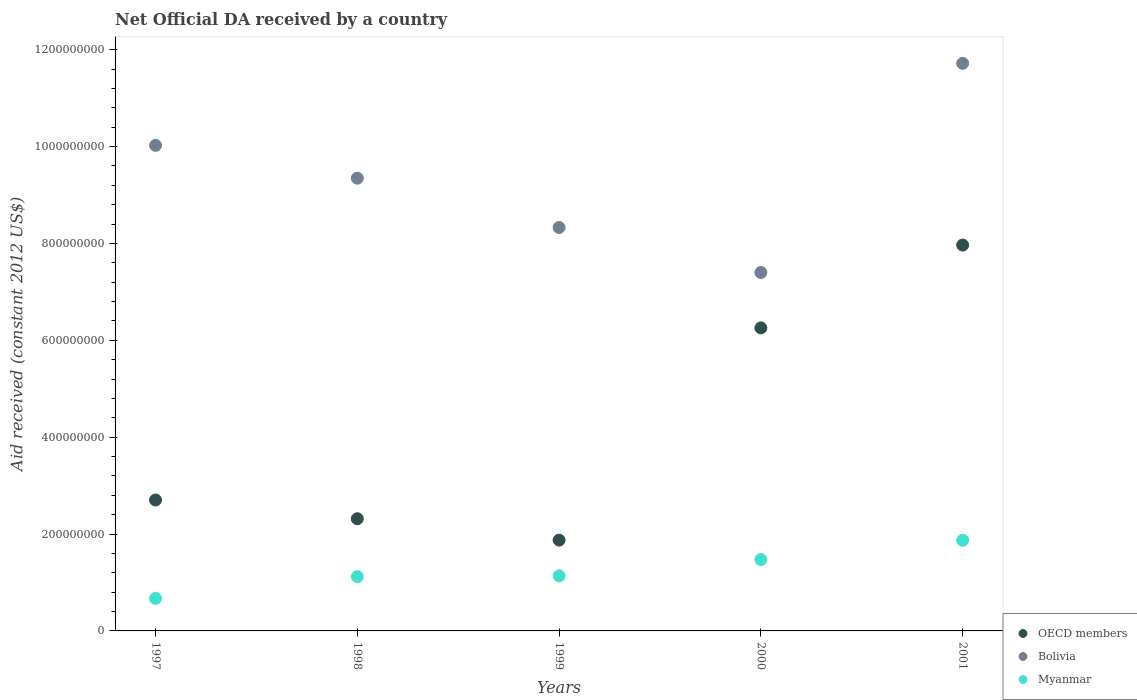How many different coloured dotlines are there?
Provide a succinct answer. 3. Is the number of dotlines equal to the number of legend labels?
Provide a short and direct response. Yes. What is the net official development assistance aid received in Bolivia in 2001?
Provide a short and direct response. 1.17e+09. Across all years, what is the maximum net official development assistance aid received in OECD members?
Provide a succinct answer. 7.97e+08. Across all years, what is the minimum net official development assistance aid received in OECD members?
Keep it short and to the point. 1.88e+08. In which year was the net official development assistance aid received in Bolivia maximum?
Offer a very short reply. 2001. What is the total net official development assistance aid received in OECD members in the graph?
Offer a terse response. 2.11e+09. What is the difference between the net official development assistance aid received in Bolivia in 2000 and that in 2001?
Ensure brevity in your answer.  -4.32e+08. What is the difference between the net official development assistance aid received in OECD members in 1997 and the net official development assistance aid received in Myanmar in 1999?
Offer a very short reply. 1.57e+08. What is the average net official development assistance aid received in OECD members per year?
Provide a succinct answer. 4.22e+08. In the year 2000, what is the difference between the net official development assistance aid received in Bolivia and net official development assistance aid received in Myanmar?
Provide a short and direct response. 5.93e+08. In how many years, is the net official development assistance aid received in Bolivia greater than 760000000 US$?
Provide a short and direct response. 4. What is the ratio of the net official development assistance aid received in Myanmar in 1998 to that in 2001?
Provide a succinct answer. 0.6. Is the net official development assistance aid received in OECD members in 1997 less than that in 2001?
Give a very brief answer. Yes. What is the difference between the highest and the second highest net official development assistance aid received in Myanmar?
Make the answer very short. 3.98e+07. What is the difference between the highest and the lowest net official development assistance aid received in OECD members?
Provide a succinct answer. 6.09e+08. In how many years, is the net official development assistance aid received in OECD members greater than the average net official development assistance aid received in OECD members taken over all years?
Offer a very short reply. 2. Does the net official development assistance aid received in Bolivia monotonically increase over the years?
Your answer should be very brief. No. Is the net official development assistance aid received in OECD members strictly greater than the net official development assistance aid received in Bolivia over the years?
Ensure brevity in your answer.  No. Is the net official development assistance aid received in Bolivia strictly less than the net official development assistance aid received in Myanmar over the years?
Your answer should be compact. No. How many years are there in the graph?
Provide a short and direct response. 5. Are the values on the major ticks of Y-axis written in scientific E-notation?
Your response must be concise. No. Where does the legend appear in the graph?
Offer a very short reply. Bottom right. How many legend labels are there?
Make the answer very short. 3. How are the legend labels stacked?
Your answer should be very brief. Vertical. What is the title of the graph?
Give a very brief answer. Net Official DA received by a country. What is the label or title of the X-axis?
Offer a very short reply. Years. What is the label or title of the Y-axis?
Make the answer very short. Aid received (constant 2012 US$). What is the Aid received (constant 2012 US$) of OECD members in 1997?
Offer a terse response. 2.70e+08. What is the Aid received (constant 2012 US$) of Bolivia in 1997?
Offer a terse response. 1.00e+09. What is the Aid received (constant 2012 US$) of Myanmar in 1997?
Provide a succinct answer. 6.71e+07. What is the Aid received (constant 2012 US$) of OECD members in 1998?
Give a very brief answer. 2.32e+08. What is the Aid received (constant 2012 US$) in Bolivia in 1998?
Offer a very short reply. 9.35e+08. What is the Aid received (constant 2012 US$) of Myanmar in 1998?
Offer a terse response. 1.12e+08. What is the Aid received (constant 2012 US$) in OECD members in 1999?
Offer a terse response. 1.88e+08. What is the Aid received (constant 2012 US$) of Bolivia in 1999?
Offer a terse response. 8.33e+08. What is the Aid received (constant 2012 US$) of Myanmar in 1999?
Provide a succinct answer. 1.14e+08. What is the Aid received (constant 2012 US$) of OECD members in 2000?
Provide a succinct answer. 6.26e+08. What is the Aid received (constant 2012 US$) in Bolivia in 2000?
Offer a terse response. 7.40e+08. What is the Aid received (constant 2012 US$) of Myanmar in 2000?
Offer a very short reply. 1.47e+08. What is the Aid received (constant 2012 US$) in OECD members in 2001?
Ensure brevity in your answer.  7.97e+08. What is the Aid received (constant 2012 US$) of Bolivia in 2001?
Provide a short and direct response. 1.17e+09. What is the Aid received (constant 2012 US$) in Myanmar in 2001?
Give a very brief answer. 1.87e+08. Across all years, what is the maximum Aid received (constant 2012 US$) of OECD members?
Your answer should be very brief. 7.97e+08. Across all years, what is the maximum Aid received (constant 2012 US$) of Bolivia?
Offer a very short reply. 1.17e+09. Across all years, what is the maximum Aid received (constant 2012 US$) of Myanmar?
Make the answer very short. 1.87e+08. Across all years, what is the minimum Aid received (constant 2012 US$) in OECD members?
Give a very brief answer. 1.88e+08. Across all years, what is the minimum Aid received (constant 2012 US$) of Bolivia?
Provide a succinct answer. 7.40e+08. Across all years, what is the minimum Aid received (constant 2012 US$) of Myanmar?
Give a very brief answer. 6.71e+07. What is the total Aid received (constant 2012 US$) in OECD members in the graph?
Keep it short and to the point. 2.11e+09. What is the total Aid received (constant 2012 US$) in Bolivia in the graph?
Provide a short and direct response. 4.68e+09. What is the total Aid received (constant 2012 US$) in Myanmar in the graph?
Provide a short and direct response. 6.28e+08. What is the difference between the Aid received (constant 2012 US$) of OECD members in 1997 and that in 1998?
Offer a very short reply. 3.87e+07. What is the difference between the Aid received (constant 2012 US$) in Bolivia in 1997 and that in 1998?
Provide a succinct answer. 6.77e+07. What is the difference between the Aid received (constant 2012 US$) in Myanmar in 1997 and that in 1998?
Your answer should be very brief. -4.50e+07. What is the difference between the Aid received (constant 2012 US$) in OECD members in 1997 and that in 1999?
Keep it short and to the point. 8.28e+07. What is the difference between the Aid received (constant 2012 US$) of Bolivia in 1997 and that in 1999?
Your answer should be very brief. 1.70e+08. What is the difference between the Aid received (constant 2012 US$) in Myanmar in 1997 and that in 1999?
Your answer should be compact. -4.66e+07. What is the difference between the Aid received (constant 2012 US$) of OECD members in 1997 and that in 2000?
Give a very brief answer. -3.55e+08. What is the difference between the Aid received (constant 2012 US$) in Bolivia in 1997 and that in 2000?
Provide a short and direct response. 2.62e+08. What is the difference between the Aid received (constant 2012 US$) of Myanmar in 1997 and that in 2000?
Your response must be concise. -8.03e+07. What is the difference between the Aid received (constant 2012 US$) of OECD members in 1997 and that in 2001?
Provide a short and direct response. -5.26e+08. What is the difference between the Aid received (constant 2012 US$) in Bolivia in 1997 and that in 2001?
Ensure brevity in your answer.  -1.69e+08. What is the difference between the Aid received (constant 2012 US$) in Myanmar in 1997 and that in 2001?
Provide a short and direct response. -1.20e+08. What is the difference between the Aid received (constant 2012 US$) in OECD members in 1998 and that in 1999?
Your answer should be very brief. 4.41e+07. What is the difference between the Aid received (constant 2012 US$) in Bolivia in 1998 and that in 1999?
Keep it short and to the point. 1.02e+08. What is the difference between the Aid received (constant 2012 US$) in Myanmar in 1998 and that in 1999?
Provide a succinct answer. -1.68e+06. What is the difference between the Aid received (constant 2012 US$) of OECD members in 1998 and that in 2000?
Make the answer very short. -3.94e+08. What is the difference between the Aid received (constant 2012 US$) of Bolivia in 1998 and that in 2000?
Make the answer very short. 1.95e+08. What is the difference between the Aid received (constant 2012 US$) in Myanmar in 1998 and that in 2000?
Ensure brevity in your answer.  -3.53e+07. What is the difference between the Aid received (constant 2012 US$) in OECD members in 1998 and that in 2001?
Your answer should be compact. -5.65e+08. What is the difference between the Aid received (constant 2012 US$) of Bolivia in 1998 and that in 2001?
Give a very brief answer. -2.37e+08. What is the difference between the Aid received (constant 2012 US$) of Myanmar in 1998 and that in 2001?
Ensure brevity in your answer.  -7.51e+07. What is the difference between the Aid received (constant 2012 US$) in OECD members in 1999 and that in 2000?
Keep it short and to the point. -4.38e+08. What is the difference between the Aid received (constant 2012 US$) in Bolivia in 1999 and that in 2000?
Provide a succinct answer. 9.29e+07. What is the difference between the Aid received (constant 2012 US$) of Myanmar in 1999 and that in 2000?
Offer a very short reply. -3.37e+07. What is the difference between the Aid received (constant 2012 US$) in OECD members in 1999 and that in 2001?
Keep it short and to the point. -6.09e+08. What is the difference between the Aid received (constant 2012 US$) of Bolivia in 1999 and that in 2001?
Your response must be concise. -3.39e+08. What is the difference between the Aid received (constant 2012 US$) in Myanmar in 1999 and that in 2001?
Offer a terse response. -7.34e+07. What is the difference between the Aid received (constant 2012 US$) of OECD members in 2000 and that in 2001?
Ensure brevity in your answer.  -1.71e+08. What is the difference between the Aid received (constant 2012 US$) in Bolivia in 2000 and that in 2001?
Make the answer very short. -4.32e+08. What is the difference between the Aid received (constant 2012 US$) of Myanmar in 2000 and that in 2001?
Offer a terse response. -3.98e+07. What is the difference between the Aid received (constant 2012 US$) in OECD members in 1997 and the Aid received (constant 2012 US$) in Bolivia in 1998?
Ensure brevity in your answer.  -6.64e+08. What is the difference between the Aid received (constant 2012 US$) in OECD members in 1997 and the Aid received (constant 2012 US$) in Myanmar in 1998?
Your answer should be very brief. 1.58e+08. What is the difference between the Aid received (constant 2012 US$) of Bolivia in 1997 and the Aid received (constant 2012 US$) of Myanmar in 1998?
Make the answer very short. 8.90e+08. What is the difference between the Aid received (constant 2012 US$) of OECD members in 1997 and the Aid received (constant 2012 US$) of Bolivia in 1999?
Provide a short and direct response. -5.63e+08. What is the difference between the Aid received (constant 2012 US$) in OECD members in 1997 and the Aid received (constant 2012 US$) in Myanmar in 1999?
Give a very brief answer. 1.57e+08. What is the difference between the Aid received (constant 2012 US$) in Bolivia in 1997 and the Aid received (constant 2012 US$) in Myanmar in 1999?
Your answer should be very brief. 8.89e+08. What is the difference between the Aid received (constant 2012 US$) in OECD members in 1997 and the Aid received (constant 2012 US$) in Bolivia in 2000?
Give a very brief answer. -4.70e+08. What is the difference between the Aid received (constant 2012 US$) in OECD members in 1997 and the Aid received (constant 2012 US$) in Myanmar in 2000?
Your response must be concise. 1.23e+08. What is the difference between the Aid received (constant 2012 US$) of Bolivia in 1997 and the Aid received (constant 2012 US$) of Myanmar in 2000?
Offer a terse response. 8.55e+08. What is the difference between the Aid received (constant 2012 US$) of OECD members in 1997 and the Aid received (constant 2012 US$) of Bolivia in 2001?
Offer a very short reply. -9.02e+08. What is the difference between the Aid received (constant 2012 US$) of OECD members in 1997 and the Aid received (constant 2012 US$) of Myanmar in 2001?
Your response must be concise. 8.32e+07. What is the difference between the Aid received (constant 2012 US$) of Bolivia in 1997 and the Aid received (constant 2012 US$) of Myanmar in 2001?
Provide a short and direct response. 8.15e+08. What is the difference between the Aid received (constant 2012 US$) of OECD members in 1998 and the Aid received (constant 2012 US$) of Bolivia in 1999?
Provide a short and direct response. -6.01e+08. What is the difference between the Aid received (constant 2012 US$) of OECD members in 1998 and the Aid received (constant 2012 US$) of Myanmar in 1999?
Keep it short and to the point. 1.18e+08. What is the difference between the Aid received (constant 2012 US$) of Bolivia in 1998 and the Aid received (constant 2012 US$) of Myanmar in 1999?
Your answer should be compact. 8.21e+08. What is the difference between the Aid received (constant 2012 US$) of OECD members in 1998 and the Aid received (constant 2012 US$) of Bolivia in 2000?
Your response must be concise. -5.08e+08. What is the difference between the Aid received (constant 2012 US$) in OECD members in 1998 and the Aid received (constant 2012 US$) in Myanmar in 2000?
Ensure brevity in your answer.  8.42e+07. What is the difference between the Aid received (constant 2012 US$) in Bolivia in 1998 and the Aid received (constant 2012 US$) in Myanmar in 2000?
Ensure brevity in your answer.  7.87e+08. What is the difference between the Aid received (constant 2012 US$) of OECD members in 1998 and the Aid received (constant 2012 US$) of Bolivia in 2001?
Offer a terse response. -9.40e+08. What is the difference between the Aid received (constant 2012 US$) in OECD members in 1998 and the Aid received (constant 2012 US$) in Myanmar in 2001?
Offer a very short reply. 4.44e+07. What is the difference between the Aid received (constant 2012 US$) in Bolivia in 1998 and the Aid received (constant 2012 US$) in Myanmar in 2001?
Your answer should be very brief. 7.48e+08. What is the difference between the Aid received (constant 2012 US$) in OECD members in 1999 and the Aid received (constant 2012 US$) in Bolivia in 2000?
Keep it short and to the point. -5.53e+08. What is the difference between the Aid received (constant 2012 US$) in OECD members in 1999 and the Aid received (constant 2012 US$) in Myanmar in 2000?
Provide a succinct answer. 4.01e+07. What is the difference between the Aid received (constant 2012 US$) of Bolivia in 1999 and the Aid received (constant 2012 US$) of Myanmar in 2000?
Ensure brevity in your answer.  6.86e+08. What is the difference between the Aid received (constant 2012 US$) in OECD members in 1999 and the Aid received (constant 2012 US$) in Bolivia in 2001?
Your answer should be compact. -9.84e+08. What is the difference between the Aid received (constant 2012 US$) of Bolivia in 1999 and the Aid received (constant 2012 US$) of Myanmar in 2001?
Provide a succinct answer. 6.46e+08. What is the difference between the Aid received (constant 2012 US$) of OECD members in 2000 and the Aid received (constant 2012 US$) of Bolivia in 2001?
Your answer should be compact. -5.46e+08. What is the difference between the Aid received (constant 2012 US$) in OECD members in 2000 and the Aid received (constant 2012 US$) in Myanmar in 2001?
Make the answer very short. 4.38e+08. What is the difference between the Aid received (constant 2012 US$) of Bolivia in 2000 and the Aid received (constant 2012 US$) of Myanmar in 2001?
Your response must be concise. 5.53e+08. What is the average Aid received (constant 2012 US$) of OECD members per year?
Give a very brief answer. 4.22e+08. What is the average Aid received (constant 2012 US$) of Bolivia per year?
Give a very brief answer. 9.36e+08. What is the average Aid received (constant 2012 US$) of Myanmar per year?
Your response must be concise. 1.26e+08. In the year 1997, what is the difference between the Aid received (constant 2012 US$) in OECD members and Aid received (constant 2012 US$) in Bolivia?
Keep it short and to the point. -7.32e+08. In the year 1997, what is the difference between the Aid received (constant 2012 US$) in OECD members and Aid received (constant 2012 US$) in Myanmar?
Your response must be concise. 2.03e+08. In the year 1997, what is the difference between the Aid received (constant 2012 US$) in Bolivia and Aid received (constant 2012 US$) in Myanmar?
Your answer should be very brief. 9.35e+08. In the year 1998, what is the difference between the Aid received (constant 2012 US$) in OECD members and Aid received (constant 2012 US$) in Bolivia?
Provide a succinct answer. -7.03e+08. In the year 1998, what is the difference between the Aid received (constant 2012 US$) of OECD members and Aid received (constant 2012 US$) of Myanmar?
Ensure brevity in your answer.  1.20e+08. In the year 1998, what is the difference between the Aid received (constant 2012 US$) of Bolivia and Aid received (constant 2012 US$) of Myanmar?
Provide a short and direct response. 8.23e+08. In the year 1999, what is the difference between the Aid received (constant 2012 US$) of OECD members and Aid received (constant 2012 US$) of Bolivia?
Offer a terse response. -6.45e+08. In the year 1999, what is the difference between the Aid received (constant 2012 US$) in OECD members and Aid received (constant 2012 US$) in Myanmar?
Offer a terse response. 7.38e+07. In the year 1999, what is the difference between the Aid received (constant 2012 US$) in Bolivia and Aid received (constant 2012 US$) in Myanmar?
Offer a terse response. 7.19e+08. In the year 2000, what is the difference between the Aid received (constant 2012 US$) in OECD members and Aid received (constant 2012 US$) in Bolivia?
Keep it short and to the point. -1.14e+08. In the year 2000, what is the difference between the Aid received (constant 2012 US$) in OECD members and Aid received (constant 2012 US$) in Myanmar?
Your response must be concise. 4.78e+08. In the year 2000, what is the difference between the Aid received (constant 2012 US$) in Bolivia and Aid received (constant 2012 US$) in Myanmar?
Give a very brief answer. 5.93e+08. In the year 2001, what is the difference between the Aid received (constant 2012 US$) in OECD members and Aid received (constant 2012 US$) in Bolivia?
Offer a very short reply. -3.75e+08. In the year 2001, what is the difference between the Aid received (constant 2012 US$) in OECD members and Aid received (constant 2012 US$) in Myanmar?
Your response must be concise. 6.10e+08. In the year 2001, what is the difference between the Aid received (constant 2012 US$) of Bolivia and Aid received (constant 2012 US$) of Myanmar?
Offer a very short reply. 9.85e+08. What is the ratio of the Aid received (constant 2012 US$) of OECD members in 1997 to that in 1998?
Your answer should be compact. 1.17. What is the ratio of the Aid received (constant 2012 US$) of Bolivia in 1997 to that in 1998?
Your response must be concise. 1.07. What is the ratio of the Aid received (constant 2012 US$) of Myanmar in 1997 to that in 1998?
Provide a short and direct response. 0.6. What is the ratio of the Aid received (constant 2012 US$) in OECD members in 1997 to that in 1999?
Ensure brevity in your answer.  1.44. What is the ratio of the Aid received (constant 2012 US$) in Bolivia in 1997 to that in 1999?
Offer a terse response. 1.2. What is the ratio of the Aid received (constant 2012 US$) of Myanmar in 1997 to that in 1999?
Offer a very short reply. 0.59. What is the ratio of the Aid received (constant 2012 US$) in OECD members in 1997 to that in 2000?
Provide a succinct answer. 0.43. What is the ratio of the Aid received (constant 2012 US$) in Bolivia in 1997 to that in 2000?
Your answer should be very brief. 1.35. What is the ratio of the Aid received (constant 2012 US$) in Myanmar in 1997 to that in 2000?
Provide a succinct answer. 0.46. What is the ratio of the Aid received (constant 2012 US$) of OECD members in 1997 to that in 2001?
Provide a succinct answer. 0.34. What is the ratio of the Aid received (constant 2012 US$) of Bolivia in 1997 to that in 2001?
Ensure brevity in your answer.  0.86. What is the ratio of the Aid received (constant 2012 US$) of Myanmar in 1997 to that in 2001?
Offer a very short reply. 0.36. What is the ratio of the Aid received (constant 2012 US$) in OECD members in 1998 to that in 1999?
Make the answer very short. 1.24. What is the ratio of the Aid received (constant 2012 US$) of Bolivia in 1998 to that in 1999?
Make the answer very short. 1.12. What is the ratio of the Aid received (constant 2012 US$) of Myanmar in 1998 to that in 1999?
Provide a succinct answer. 0.99. What is the ratio of the Aid received (constant 2012 US$) in OECD members in 1998 to that in 2000?
Your answer should be compact. 0.37. What is the ratio of the Aid received (constant 2012 US$) of Bolivia in 1998 to that in 2000?
Keep it short and to the point. 1.26. What is the ratio of the Aid received (constant 2012 US$) of Myanmar in 1998 to that in 2000?
Make the answer very short. 0.76. What is the ratio of the Aid received (constant 2012 US$) of OECD members in 1998 to that in 2001?
Make the answer very short. 0.29. What is the ratio of the Aid received (constant 2012 US$) of Bolivia in 1998 to that in 2001?
Give a very brief answer. 0.8. What is the ratio of the Aid received (constant 2012 US$) in Myanmar in 1998 to that in 2001?
Offer a very short reply. 0.6. What is the ratio of the Aid received (constant 2012 US$) in OECD members in 1999 to that in 2000?
Make the answer very short. 0.3. What is the ratio of the Aid received (constant 2012 US$) of Bolivia in 1999 to that in 2000?
Your answer should be very brief. 1.13. What is the ratio of the Aid received (constant 2012 US$) of Myanmar in 1999 to that in 2000?
Your answer should be compact. 0.77. What is the ratio of the Aid received (constant 2012 US$) of OECD members in 1999 to that in 2001?
Your response must be concise. 0.24. What is the ratio of the Aid received (constant 2012 US$) of Bolivia in 1999 to that in 2001?
Offer a very short reply. 0.71. What is the ratio of the Aid received (constant 2012 US$) in Myanmar in 1999 to that in 2001?
Keep it short and to the point. 0.61. What is the ratio of the Aid received (constant 2012 US$) of OECD members in 2000 to that in 2001?
Make the answer very short. 0.79. What is the ratio of the Aid received (constant 2012 US$) in Bolivia in 2000 to that in 2001?
Ensure brevity in your answer.  0.63. What is the ratio of the Aid received (constant 2012 US$) of Myanmar in 2000 to that in 2001?
Your answer should be compact. 0.79. What is the difference between the highest and the second highest Aid received (constant 2012 US$) in OECD members?
Provide a succinct answer. 1.71e+08. What is the difference between the highest and the second highest Aid received (constant 2012 US$) of Bolivia?
Your answer should be very brief. 1.69e+08. What is the difference between the highest and the second highest Aid received (constant 2012 US$) of Myanmar?
Offer a terse response. 3.98e+07. What is the difference between the highest and the lowest Aid received (constant 2012 US$) in OECD members?
Offer a very short reply. 6.09e+08. What is the difference between the highest and the lowest Aid received (constant 2012 US$) of Bolivia?
Offer a very short reply. 4.32e+08. What is the difference between the highest and the lowest Aid received (constant 2012 US$) of Myanmar?
Your answer should be very brief. 1.20e+08. 